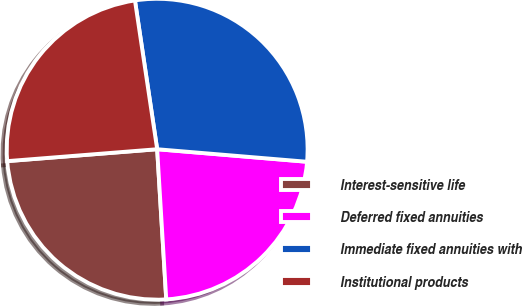Convert chart to OTSL. <chart><loc_0><loc_0><loc_500><loc_500><pie_chart><fcel>Interest-sensitive life<fcel>Deferred fixed annuities<fcel>Immediate fixed annuities with<fcel>Institutional products<nl><fcel>24.7%<fcel>22.71%<fcel>28.69%<fcel>23.9%<nl></chart> 